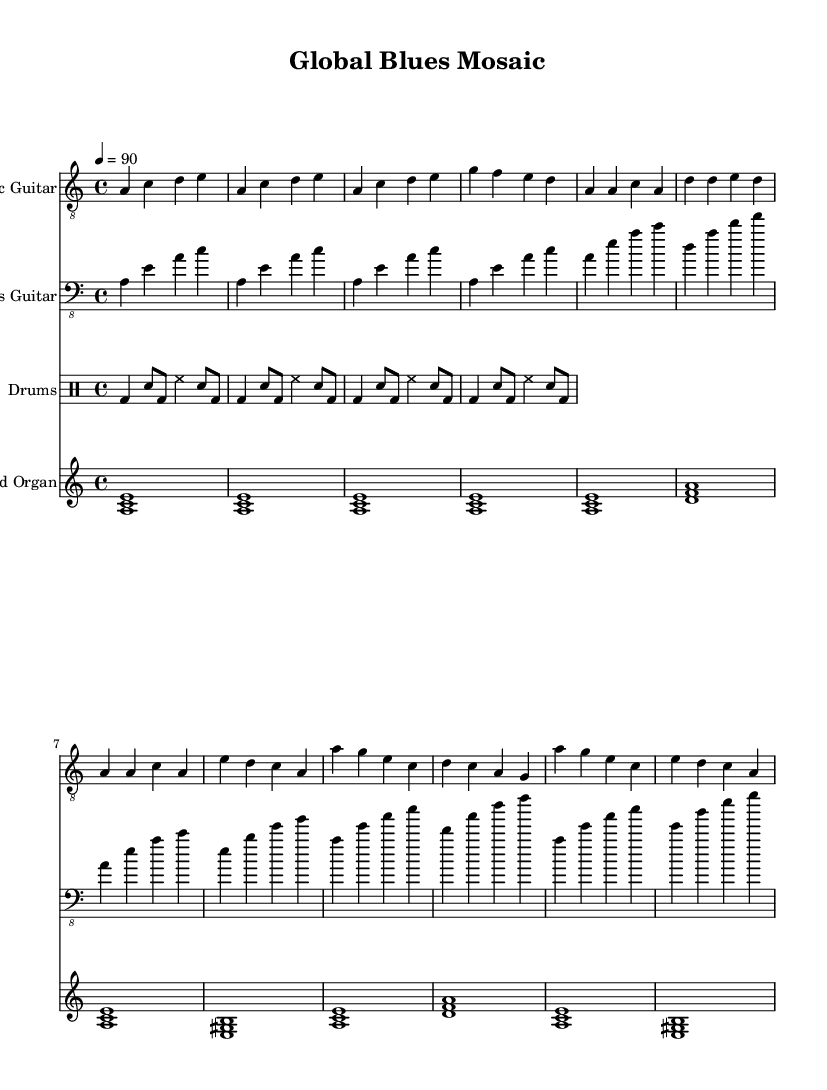What is the key signature of this music? The key signature is A minor, which has no sharps or flats. The presence of the A note indicates it's key.
Answer: A minor What is the time signature of the piece? The time signature is 4/4, which can be determined from the notation appearing at the beginning of the sheet music, indicating four beats per measure.
Answer: 4/4 What is the tempo marking given for this piece? The tempo marking is quarter note equals 90, which suggests how fast the piece is intended to be played. This is indicated at the start of the score.
Answer: 90 How many measures are in the intro section of the electric guitar? The intro section contains four measures. This can be counted directly from the notation presented in the electric guitar part.
Answer: 4 What type of rhythm pattern is used in the drums? The rhythm pattern used is a basic blues shuffle, as indicated by the typical notation and style represented in the drum part of the sheet music.
Answer: Shuffle What is the first chord played in the organ part? The first chord played in the organ part is an A minor chord, which is indicated by the grouping of the notes A, C, and E that are sustained.
Answer: A minor What is the role of the bass guitar in this music piece? The role of the bass guitar is to provide the harmonic foundation by playing the root notes and outlining the chords of the piece, which can be seen in its melodic content.
Answer: Harmonic foundation 